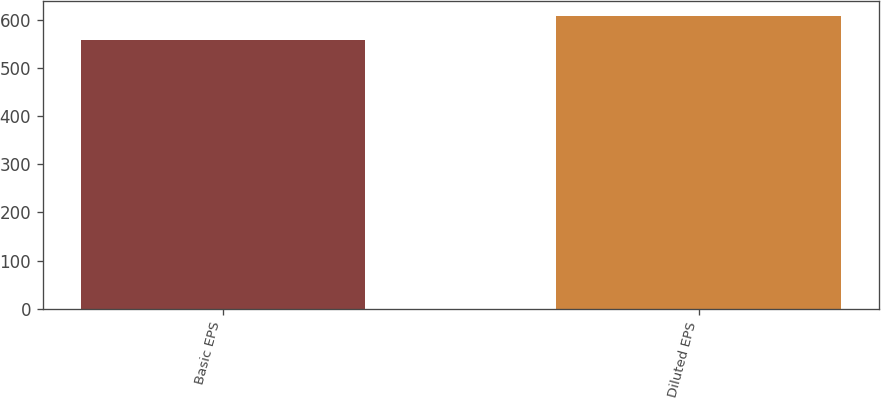Convert chart. <chart><loc_0><loc_0><loc_500><loc_500><bar_chart><fcel>Basic EPS<fcel>Diluted EPS<nl><fcel>557.8<fcel>607.7<nl></chart> 